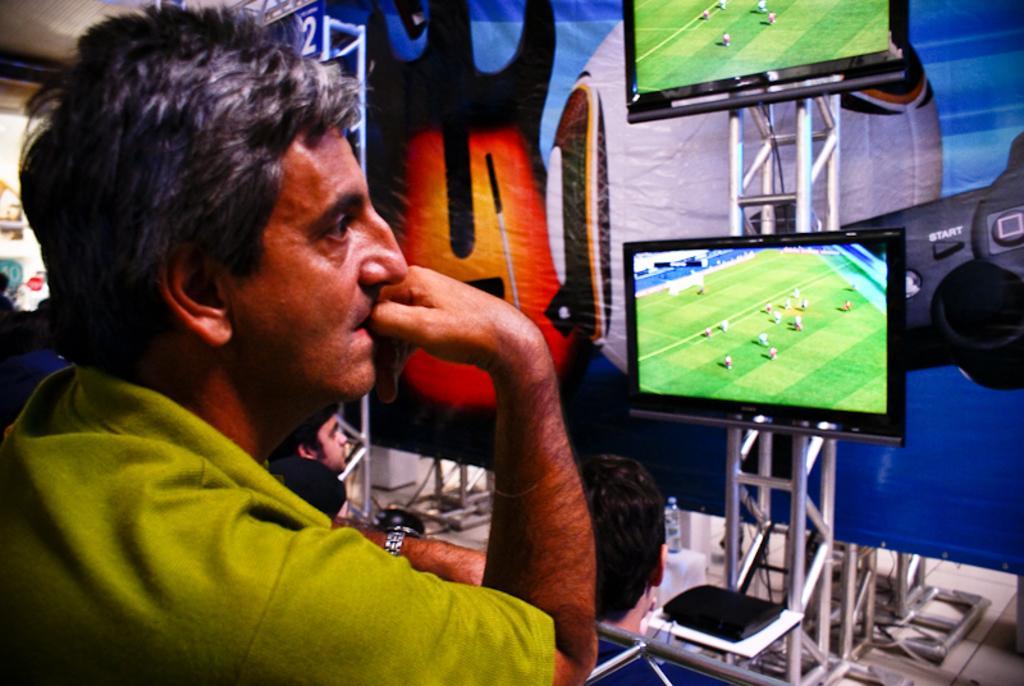Could you give a brief overview of what you see in this image? On the left side of the image we can see person standing. On the right side we can see persons, screens, water bottle and poster. 